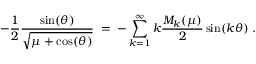<formula> <loc_0><loc_0><loc_500><loc_500>- \frac { 1 } { 2 } \frac { \sin ( \theta ) } { \sqrt { \mu + \cos ( \theta ) } } \, = \, - \sum _ { k = 1 } ^ { \infty } k \frac { M _ { k } ( \mu ) } { 2 } \sin ( k \theta ) \, .</formula> 